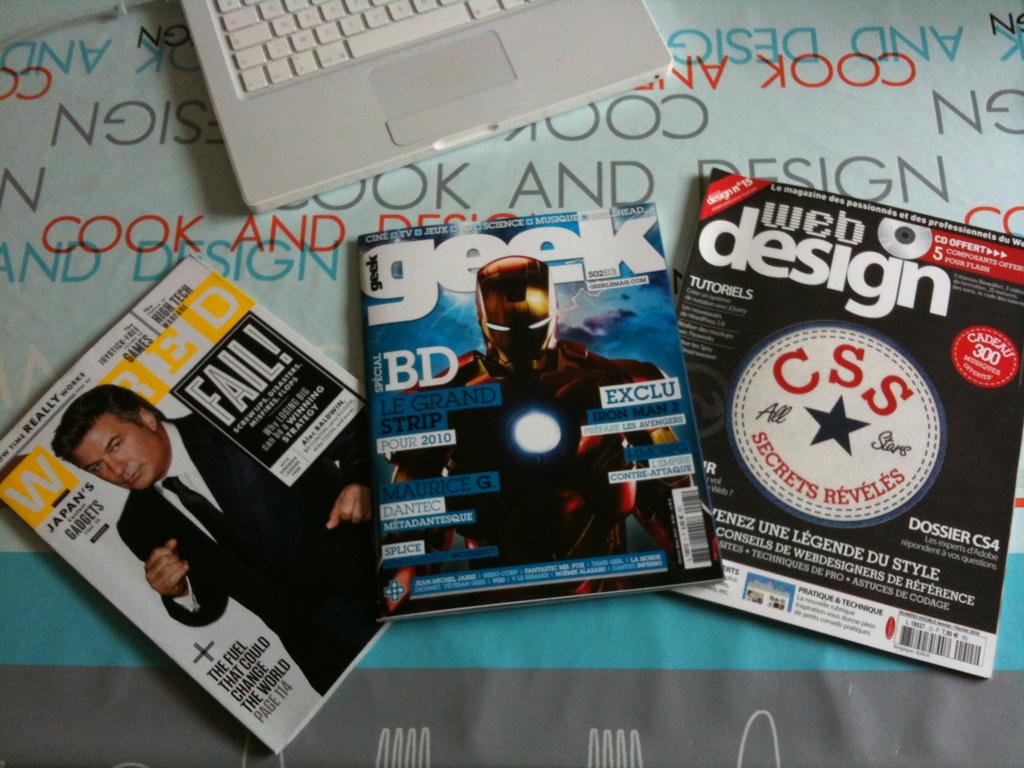What is the name of the magazine in the middle?
Your answer should be very brief. Geek. What magazine is on the right?
Offer a very short reply. Web design. 